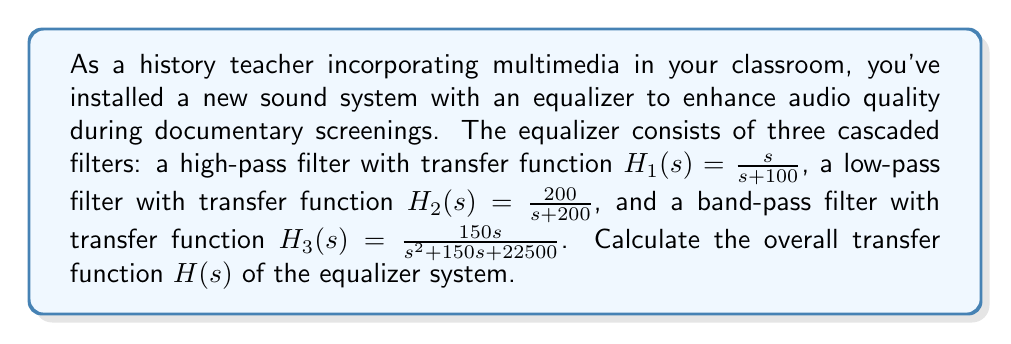Show me your answer to this math problem. To solve this problem, we need to follow these steps:

1. Recall that for cascaded systems, the overall transfer function is the product of individual transfer functions.

2. Given:
   $H_1(s) = \frac{s}{s+100}$ (high-pass filter)
   $H_2(s) = \frac{200}{s+200}$ (low-pass filter)
   $H_3(s) = \frac{150s}{s^2+150s+22500}$ (band-pass filter)

3. Calculate $H(s) = H_1(s) \cdot H_2(s) \cdot H_3(s)$:

   $$\begin{aligned}
   H(s) &= \frac{s}{s+100} \cdot \frac{200}{s+200} \cdot \frac{150s}{s^2+150s+22500} \\[10pt]
   &= \frac{200 \cdot 150s^2}{(s+100)(s+200)(s^2+150s+22500)} \\[10pt]
   &= \frac{30000s^2}{(s+100)(s+200)(s^2+150s+22500)}
   \end{aligned}$$

4. The denominator can be expanded, but it's often left in factored form for easier analysis of system behavior.

Thus, the overall transfer function of the equalizer system is:

$$H(s) = \frac{30000s^2}{(s+100)(s+200)(s^2+150s+22500)}$$

This transfer function represents how the equalizer modifies the input audio signal across different frequencies, combining the effects of the high-pass, low-pass, and band-pass filters.
Answer: $$H(s) = \frac{30000s^2}{(s+100)(s+200)(s^2+150s+22500)}$$ 